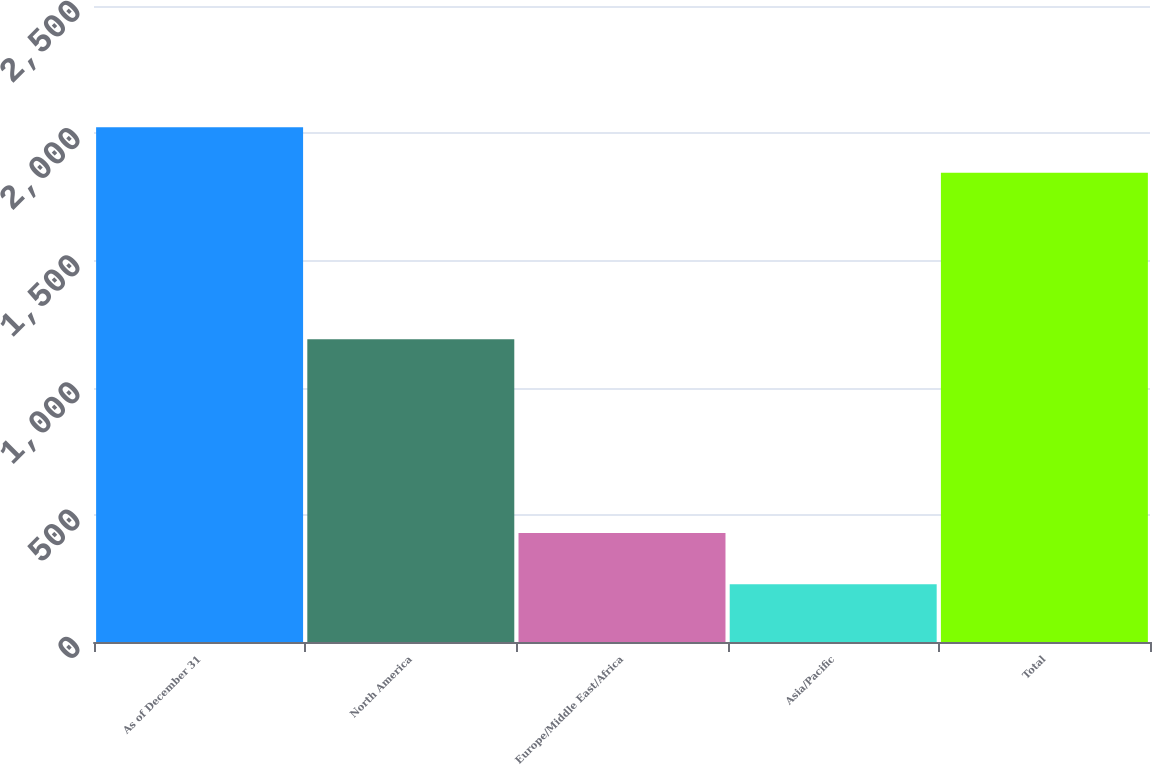Convert chart. <chart><loc_0><loc_0><loc_500><loc_500><bar_chart><fcel>As of December 31<fcel>North America<fcel>Europe/Middle East/Africa<fcel>Asia/Pacific<fcel>Total<nl><fcel>2023.4<fcel>1190<fcel>428<fcel>227<fcel>1845<nl></chart> 